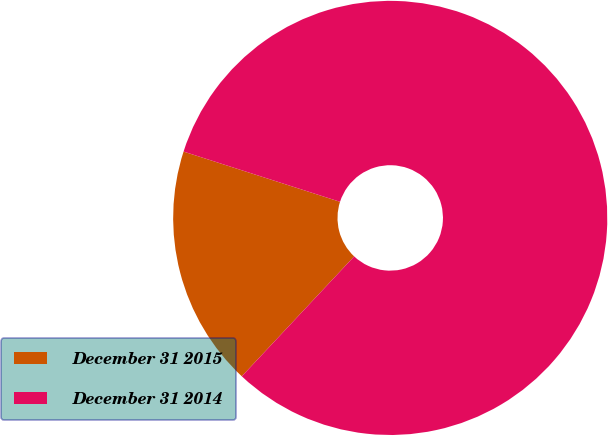<chart> <loc_0><loc_0><loc_500><loc_500><pie_chart><fcel>December 31 2015<fcel>December 31 2014<nl><fcel>17.96%<fcel>82.04%<nl></chart> 